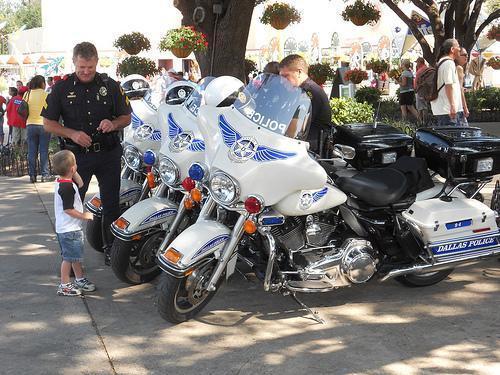How many kids are pictured?
Give a very brief answer. 1. 